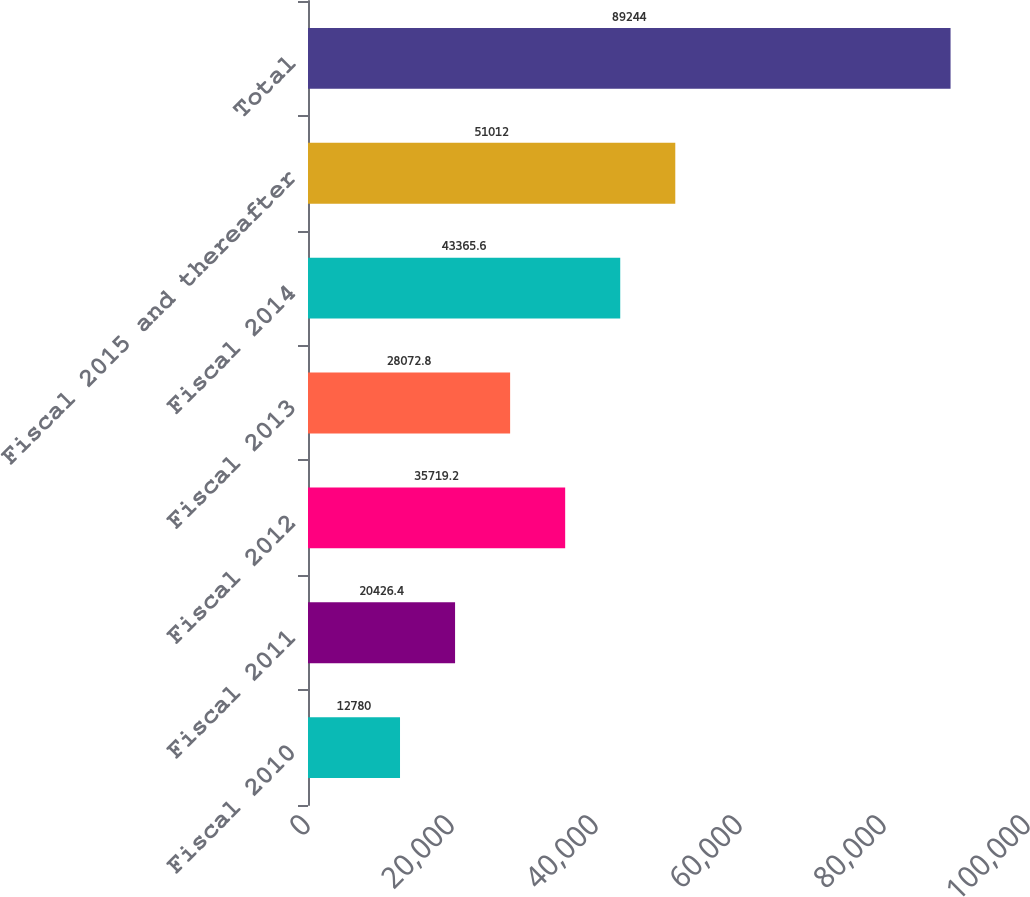Convert chart to OTSL. <chart><loc_0><loc_0><loc_500><loc_500><bar_chart><fcel>Fiscal 2010<fcel>Fiscal 2011<fcel>Fiscal 2012<fcel>Fiscal 2013<fcel>Fiscal 2014<fcel>Fiscal 2015 and thereafter<fcel>Total<nl><fcel>12780<fcel>20426.4<fcel>35719.2<fcel>28072.8<fcel>43365.6<fcel>51012<fcel>89244<nl></chart> 